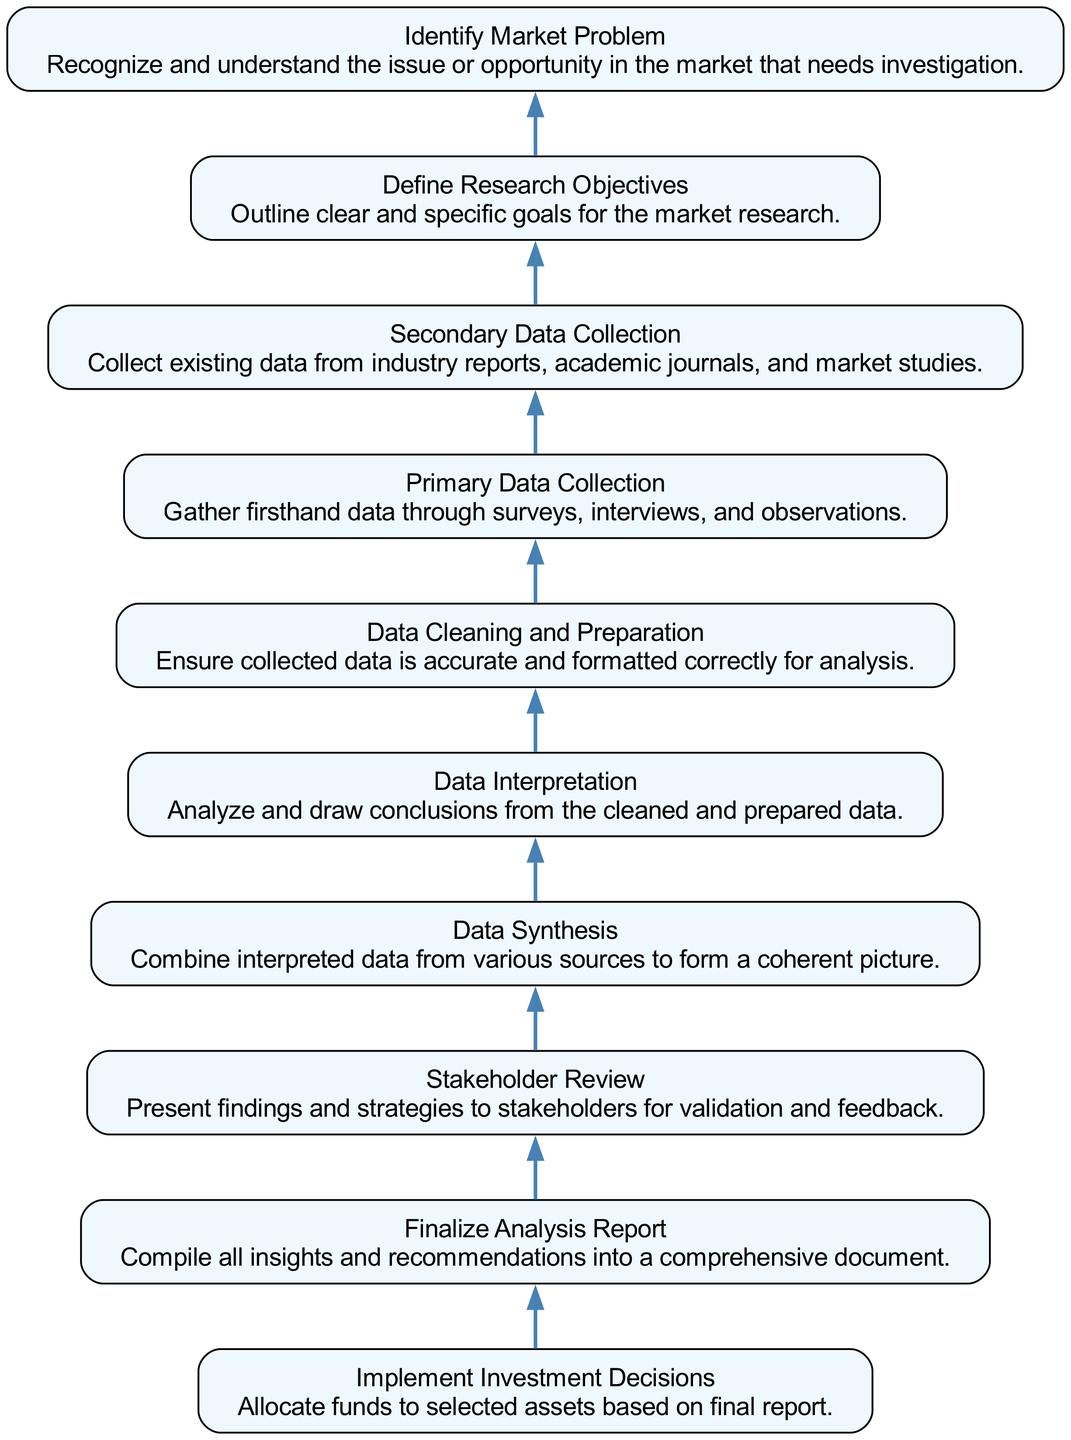What is the final step in the process? The diagram indicates that the last step before implementation is "Finalize Analysis Report," which is step 2, where insights and recommendations are compiled.
Answer: Finalize Analysis Report How many total steps are there in the diagram? By looking at the nodes presented in the diagram, there are ten distinct steps ranging from defining research objectives to implementing investment decisions.
Answer: Ten What node precedes Data Synthesis? According to the diagram, the node that directly comes before "Data Synthesis" is "Data Interpretation," which is step 5, indicating that data must be interpreted before synthesis.
Answer: Data Interpretation Which step involves gathering firsthand data? The step dedicated to the collection of firsthand data is labeled "Primary Data Collection," which is step 7 in the sequence, where data is gathered through surveys, interviews, and observations.
Answer: Primary Data Collection In the second step, what is being compiled? The second step in the process, "Finalize Analysis Report," involves compiling all insights and recommendations into a comprehensive document, ensuring clarity and completeness in the reporting process.
Answer: Insights and recommendations What is the relationship between "Identify Market Problem" and "Define Research Objectives"? The diagram shows that "Identify Market Problem" is the first node (step 10) and directly feeds into "Define Research Objectives" (step 9), indicating that understanding the market issue leads to outlining specific research goals.
Answer: Sequential dependency What type of data is processed in the sixth step? The sixth step, "Data Cleaning and Preparation," focuses on ensuring the accuracy and correct formatting of the collected data to make it suitable for subsequent analysis, which involves processing both primary and secondary data collected earlier.
Answer: Both primary and secondary data What is the starting point of the diagram? The first step in the diagram is "Identify Market Problem," which establishes the foundation for the entire market research process by recognizing the issue or opportunity that requires investigation.
Answer: Identify Market Problem Which step follows "Stakeholder Review"? The step that immediately follows "Stakeholder Review" is "Implement Investment Decisions," indicating that after validating findings and strategies with stakeholders, the implementation of those decisions takes place.
Answer: Implement Investment Decisions 